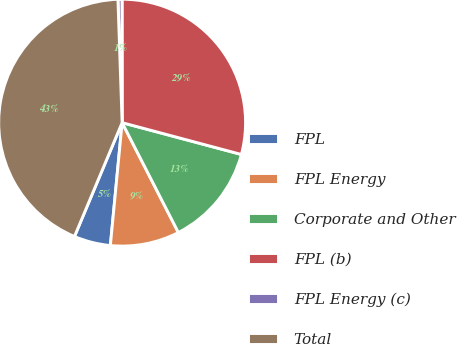Convert chart to OTSL. <chart><loc_0><loc_0><loc_500><loc_500><pie_chart><fcel>FPL<fcel>FPL Energy<fcel>Corporate and Other<fcel>FPL (b)<fcel>FPL Energy (c)<fcel>Total<nl><fcel>4.79%<fcel>9.05%<fcel>13.32%<fcel>29.16%<fcel>0.53%<fcel>43.15%<nl></chart> 